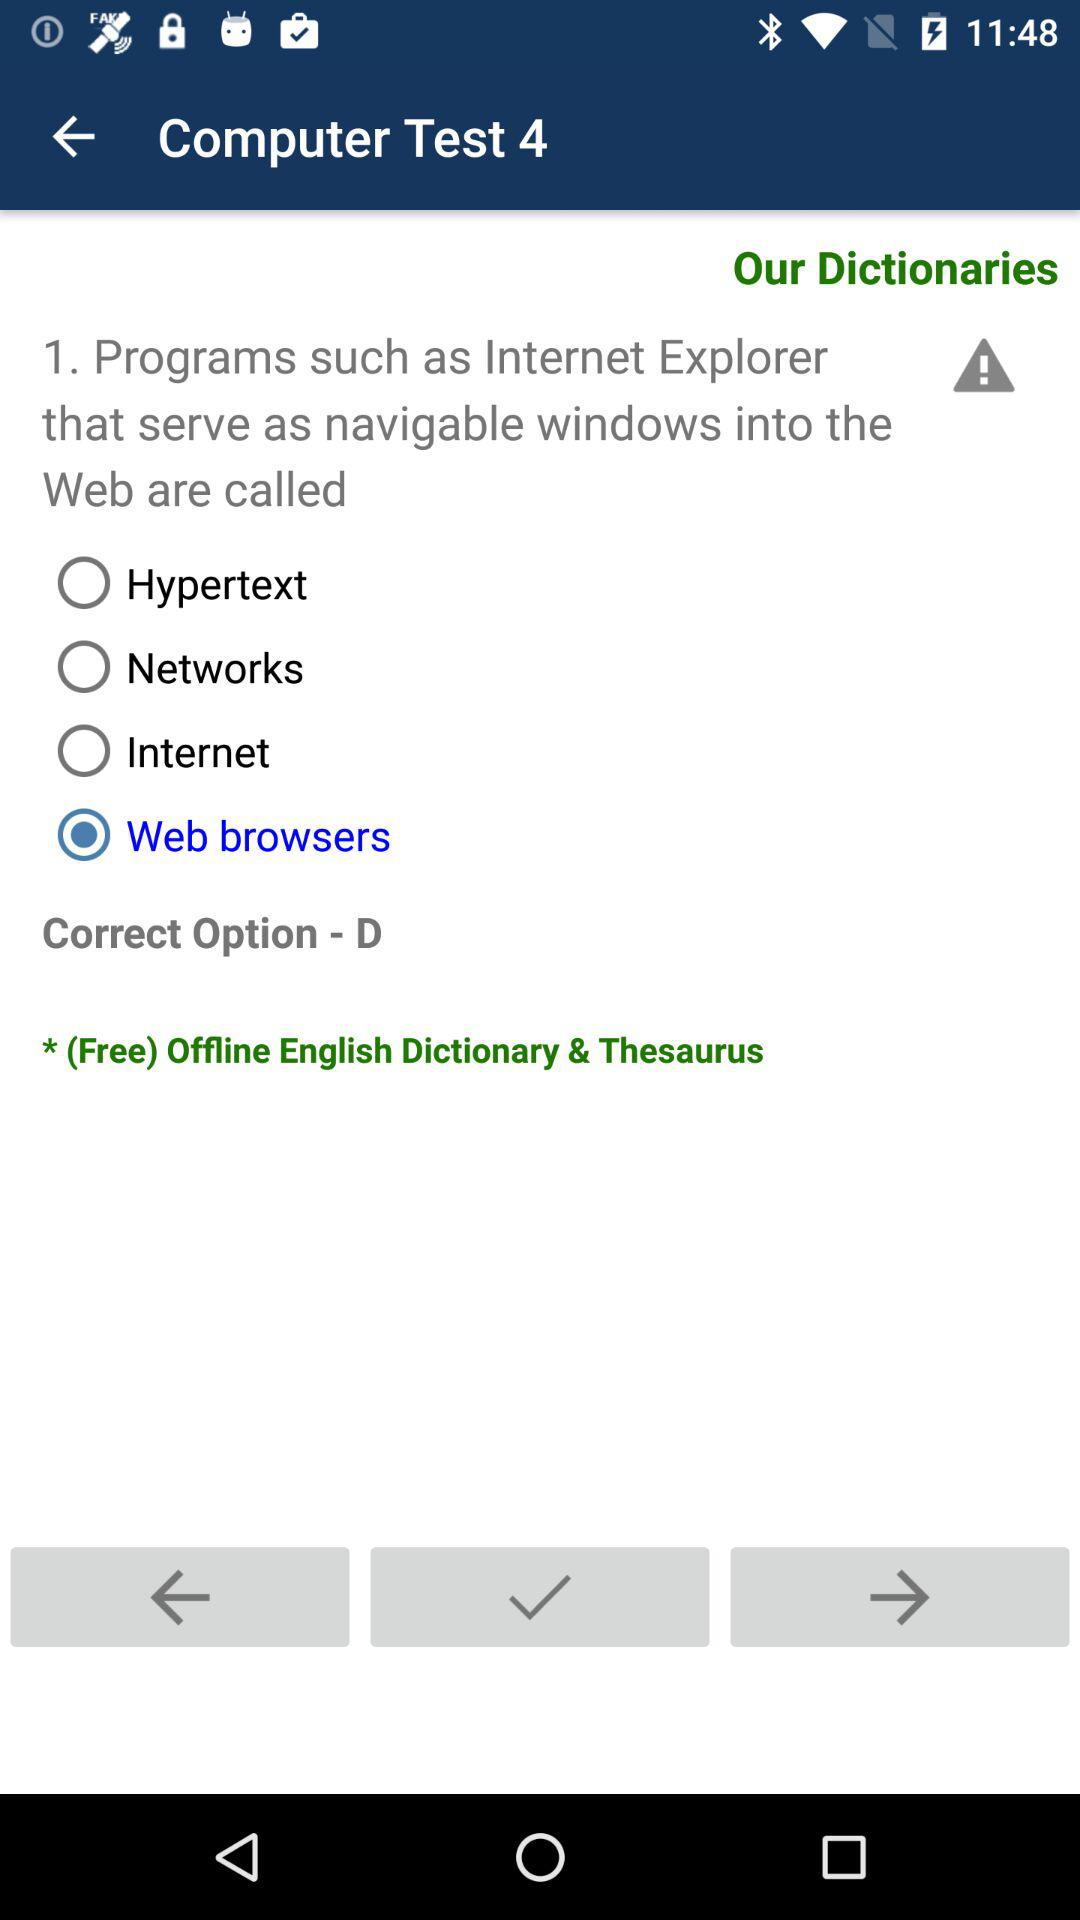What is the series number of this computer test? The series number is 4. 